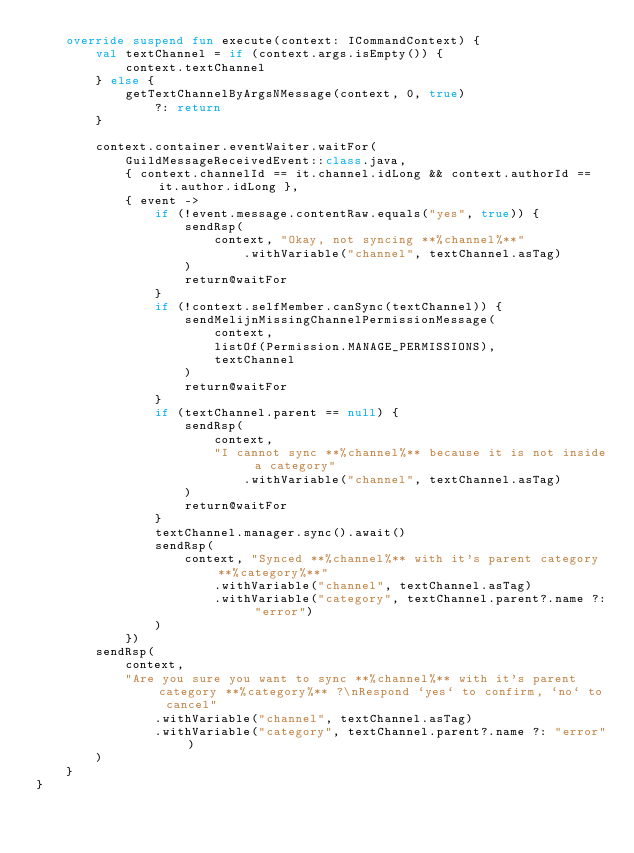<code> <loc_0><loc_0><loc_500><loc_500><_Kotlin_>    override suspend fun execute(context: ICommandContext) {
        val textChannel = if (context.args.isEmpty()) {
            context.textChannel
        } else {
            getTextChannelByArgsNMessage(context, 0, true)
                ?: return
        }

        context.container.eventWaiter.waitFor(
            GuildMessageReceivedEvent::class.java,
            { context.channelId == it.channel.idLong && context.authorId == it.author.idLong },
            { event ->
                if (!event.message.contentRaw.equals("yes", true)) {
                    sendRsp(
                        context, "Okay, not syncing **%channel%**"
                            .withVariable("channel", textChannel.asTag)
                    )
                    return@waitFor
                }
                if (!context.selfMember.canSync(textChannel)) {
                    sendMelijnMissingChannelPermissionMessage(
                        context,
                        listOf(Permission.MANAGE_PERMISSIONS),
                        textChannel
                    )
                    return@waitFor
                }
                if (textChannel.parent == null) {
                    sendRsp(
                        context,
                        "I cannot sync **%channel%** because it is not inside a category"
                            .withVariable("channel", textChannel.asTag)
                    )
                    return@waitFor
                }
                textChannel.manager.sync().await()
                sendRsp(
                    context, "Synced **%channel%** with it's parent category **%category%**"
                        .withVariable("channel", textChannel.asTag)
                        .withVariable("category", textChannel.parent?.name ?: "error")
                )
            })
        sendRsp(
            context,
            "Are you sure you want to sync **%channel%** with it's parent category **%category%** ?\nRespond `yes` to confirm, `no` to cancel"
                .withVariable("channel", textChannel.asTag)
                .withVariable("category", textChannel.parent?.name ?: "error")
        )
    }
}</code> 